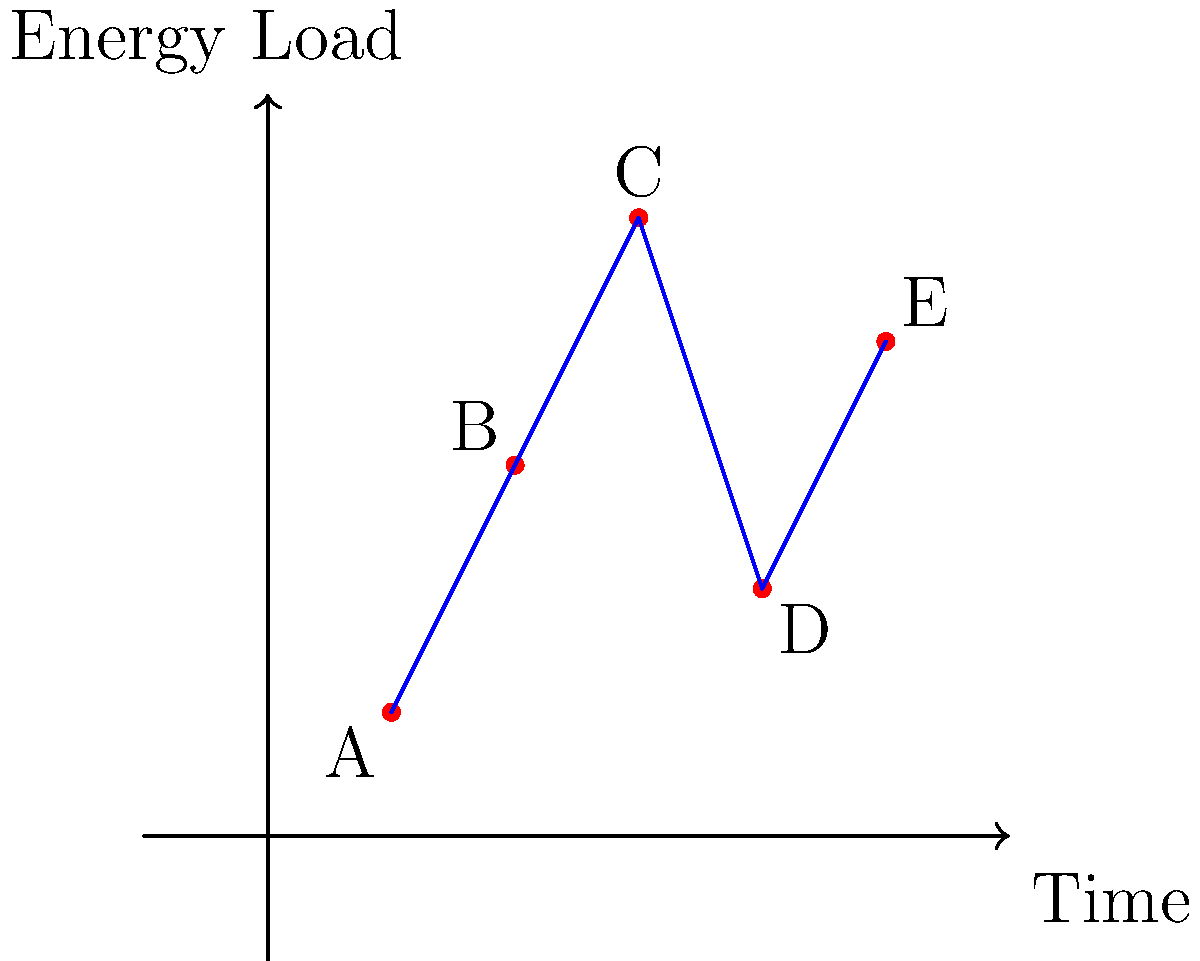In a smart grid powered by waste-to-energy conversion, the energy load varies throughout the day as shown in the graph. If the maximum capacity of the waste-to-energy plant is 4 units, what is the optimal load balancing strategy to minimize energy wastage and ensure consistent power supply? To determine the optimal load balancing strategy, we need to analyze the energy load pattern and the plant's capacity:

1. Observe the energy load pattern:
   A (1,1) → B (2,3) → C (3,5) → D (4,2) → E (5,4)

2. Identify peak loads:
   Point C (3,5) exceeds the plant's capacity of 4 units.

3. Calculate excess energy at peak:
   Excess at C = 5 - 4 = 1 unit

4. Identify low demand periods:
   Points A (1,1) and D (4,2) have lower demand.

5. Determine energy storage needs:
   Store 1 unit during low demand to use during peak at C.

6. Develop load balancing strategy:
   a) Operate at full capacity (4 units) during low demand periods.
   b) Store excess energy (3 units at A, 2 units at D).
   c) Use stored energy to supplement the 1 unit shortfall at C.
   d) Maintain consistent 4-unit output at B and E.

7. Optimize waste-to-energy conversion:
   Adjust waste processing to match the 4-unit capacity consistently.

The optimal strategy is to maintain a constant 4-unit output, storing excess during low demand and using stored energy during peak demand, ensuring consistent power supply and minimizing energy wastage.
Answer: Constant 4-unit output with energy storage 